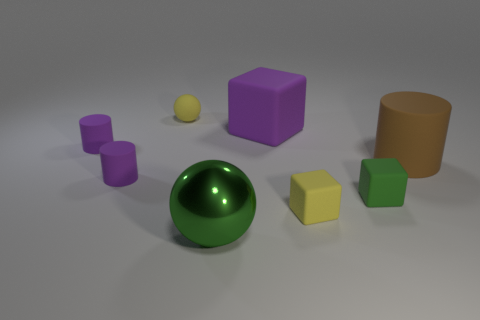Subtract all green cylinders. Subtract all purple blocks. How many cylinders are left? 3 Add 1 rubber cylinders. How many objects exist? 9 Subtract all balls. How many objects are left? 6 Subtract all tiny green rubber cylinders. Subtract all tiny objects. How many objects are left? 3 Add 1 big cylinders. How many big cylinders are left? 2 Add 4 brown matte cylinders. How many brown matte cylinders exist? 5 Subtract 1 purple blocks. How many objects are left? 7 